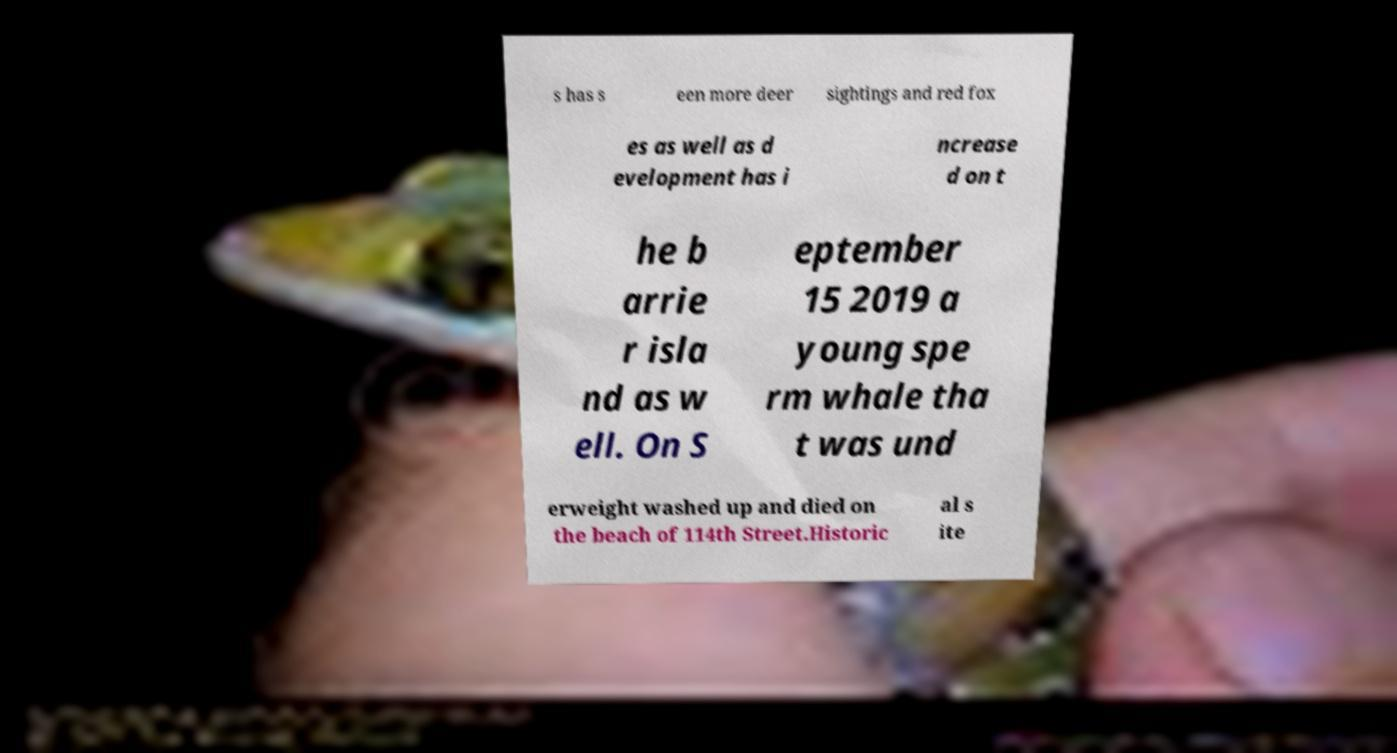There's text embedded in this image that I need extracted. Can you transcribe it verbatim? s has s een more deer sightings and red fox es as well as d evelopment has i ncrease d on t he b arrie r isla nd as w ell. On S eptember 15 2019 a young spe rm whale tha t was und erweight washed up and died on the beach of 114th Street.Historic al s ite 